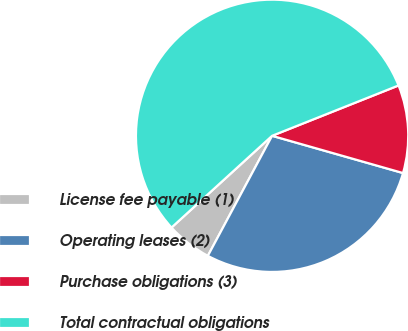Convert chart to OTSL. <chart><loc_0><loc_0><loc_500><loc_500><pie_chart><fcel>License fee payable (1)<fcel>Operating leases (2)<fcel>Purchase obligations (3)<fcel>Total contractual obligations<nl><fcel>5.41%<fcel>28.41%<fcel>10.44%<fcel>55.74%<nl></chart> 